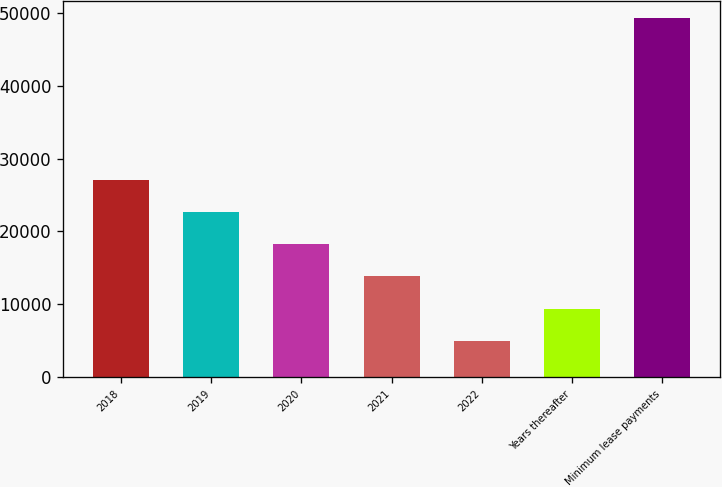Convert chart to OTSL. <chart><loc_0><loc_0><loc_500><loc_500><bar_chart><fcel>2018<fcel>2019<fcel>2020<fcel>2021<fcel>2022<fcel>Years thereafter<fcel>Minimum lease payments<nl><fcel>27120.5<fcel>22697.8<fcel>18275.1<fcel>13852.4<fcel>5007<fcel>9429.7<fcel>49234<nl></chart> 